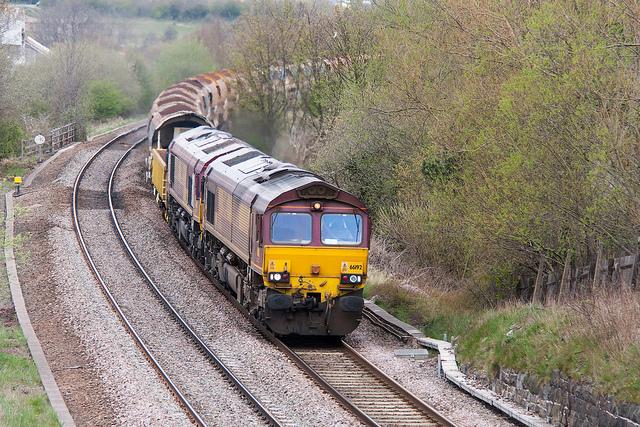Is this a rural scene?
Give a very brief answer. Yes. Is the train in motion?
Keep it brief. Yes. Is the conductor visible in the photo?
Give a very brief answer. No. 